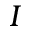Convert formula to latex. <formula><loc_0><loc_0><loc_500><loc_500>I</formula> 